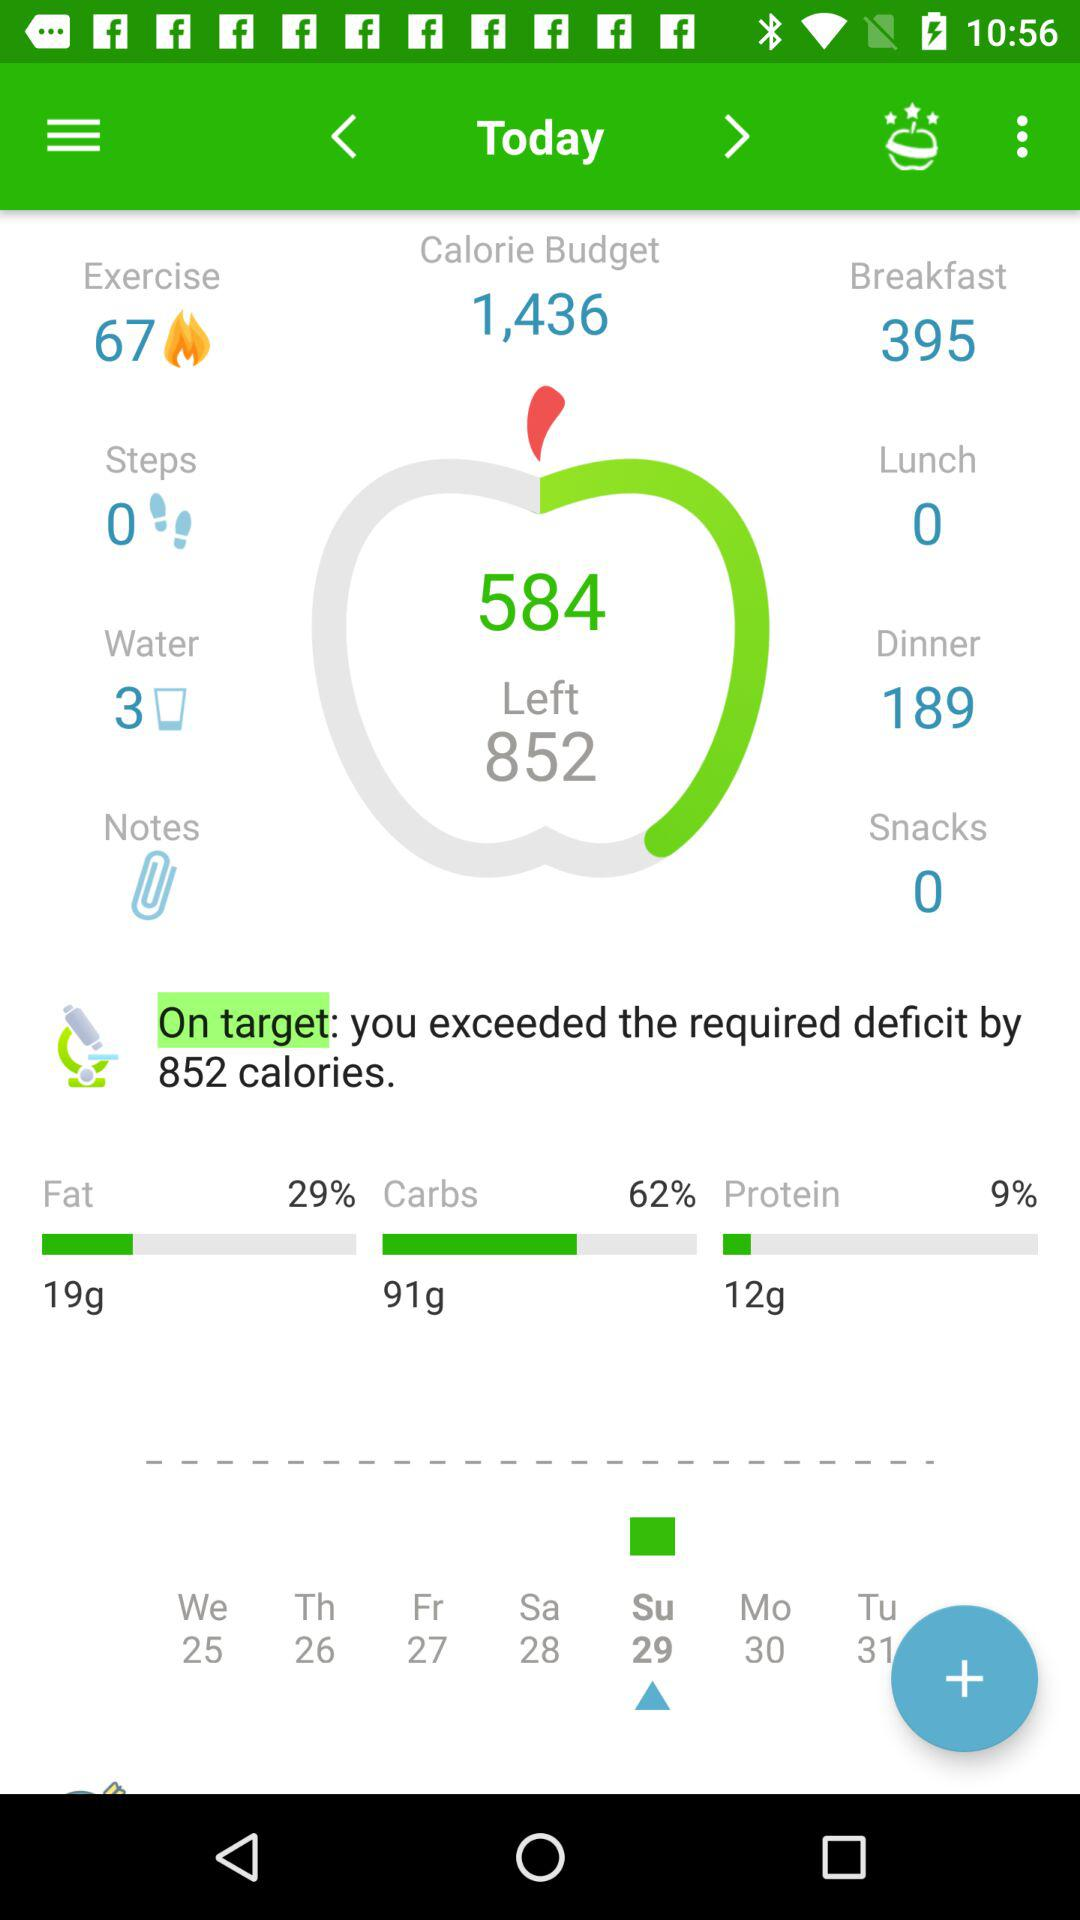What is the calorie budget? The calorie budget is 1,436. 